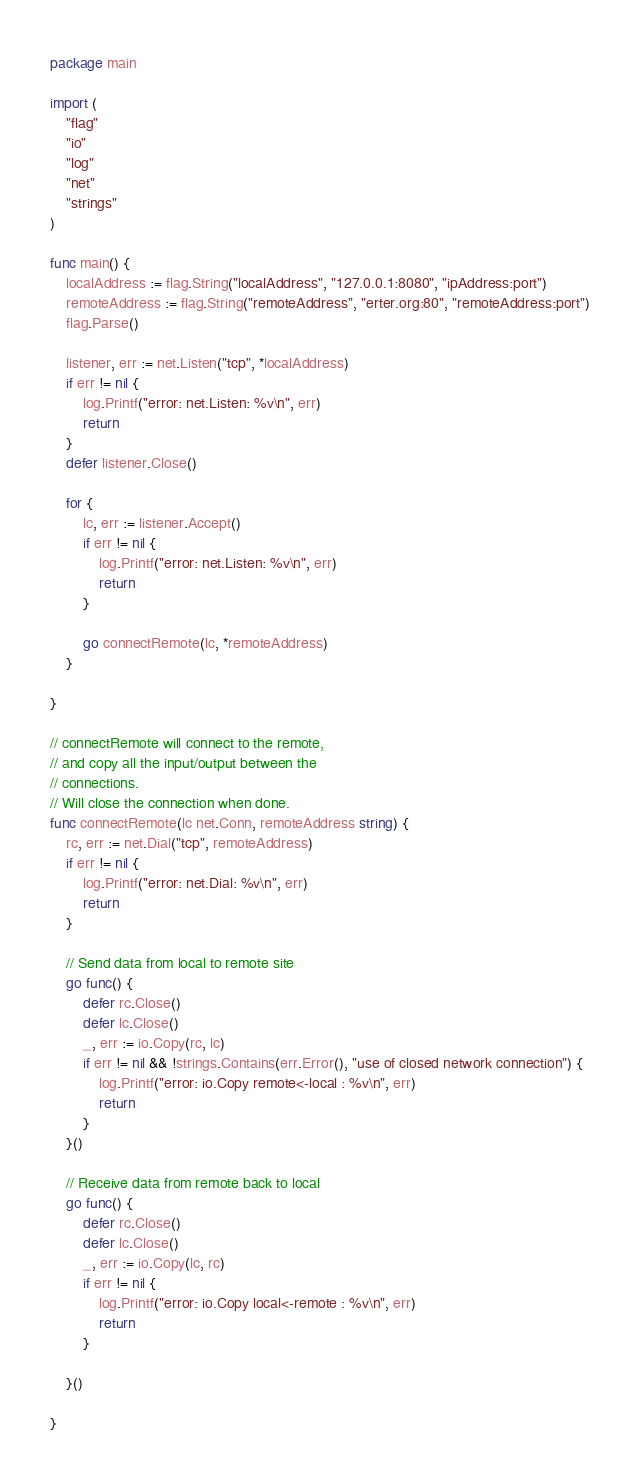<code> <loc_0><loc_0><loc_500><loc_500><_Go_>package main

import (
	"flag"
	"io"
	"log"
	"net"
	"strings"
)

func main() {
	localAddress := flag.String("localAddress", "127.0.0.1:8080", "ipAddress:port")
	remoteAddress := flag.String("remoteAddress", "erter.org:80", "remoteAddress:port")
	flag.Parse()

	listener, err := net.Listen("tcp", *localAddress)
	if err != nil {
		log.Printf("error: net.Listen: %v\n", err)
		return
	}
	defer listener.Close()

	for {
		lc, err := listener.Accept()
		if err != nil {
			log.Printf("error: net.Listen: %v\n", err)
			return
		}

		go connectRemote(lc, *remoteAddress)
	}

}

// connectRemote will connect to the remote,
// and copy all the input/output between the
// connections.
// Will close the connection when done.
func connectRemote(lc net.Conn, remoteAddress string) {
	rc, err := net.Dial("tcp", remoteAddress)
	if err != nil {
		log.Printf("error: net.Dial: %v\n", err)
		return
	}

	// Send data from local to remote site
	go func() {
		defer rc.Close()
		defer lc.Close()
		_, err := io.Copy(rc, lc)
		if err != nil && !strings.Contains(err.Error(), "use of closed network connection") {
			log.Printf("error: io.Copy remote<-local : %v\n", err)
			return
		}
	}()

	// Receive data from remote back to local
	go func() {
		defer rc.Close()
		defer lc.Close()
		_, err := io.Copy(lc, rc)
		if err != nil {
			log.Printf("error: io.Copy local<-remote : %v\n", err)
			return
		}

	}()

}
</code> 